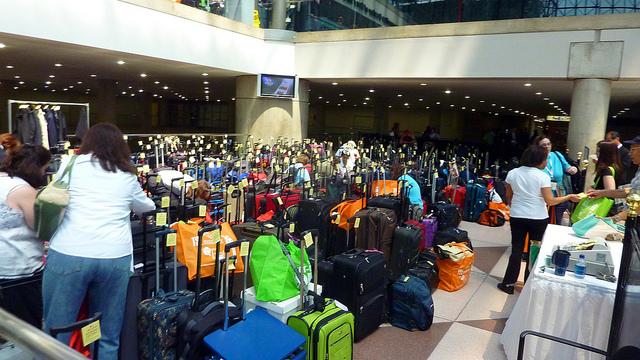What is the collective name for the great number of suitcases in this picture?
Concise answer only. Luggage. Is this picture taken outside?
Short answer required. No. Are the people at an airport?
Quick response, please. Yes. Is the television monitor in this photo on?
Keep it brief. Yes. What colors are in the shades?
Answer briefly. White. 